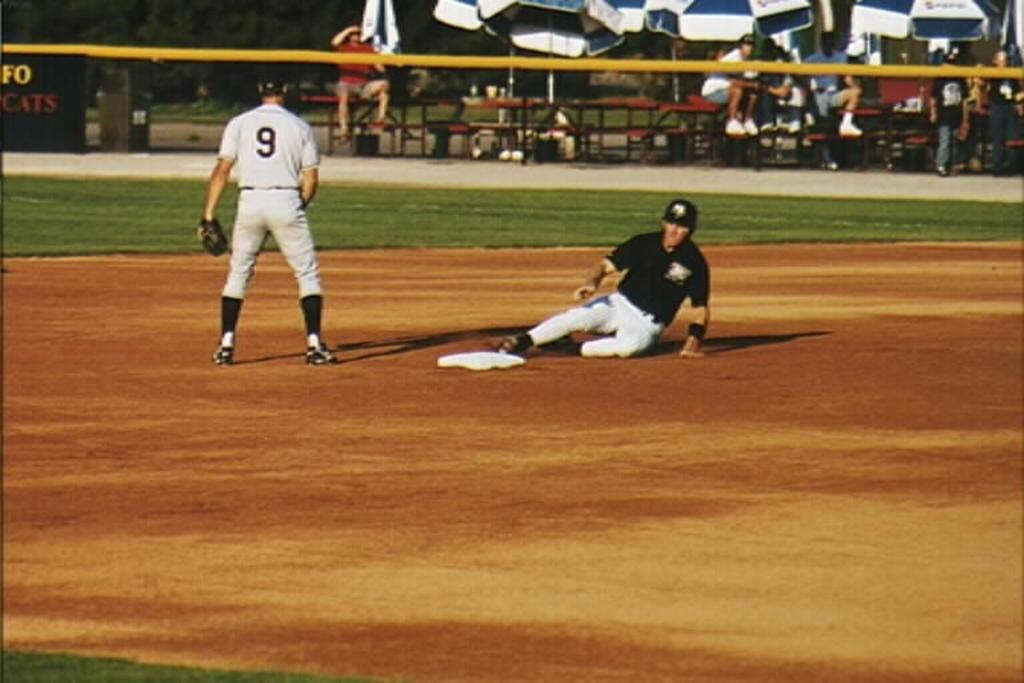Provide a one-sentence caption for the provided image. Player number 9 stands near a base as an opponent slides in safe. 